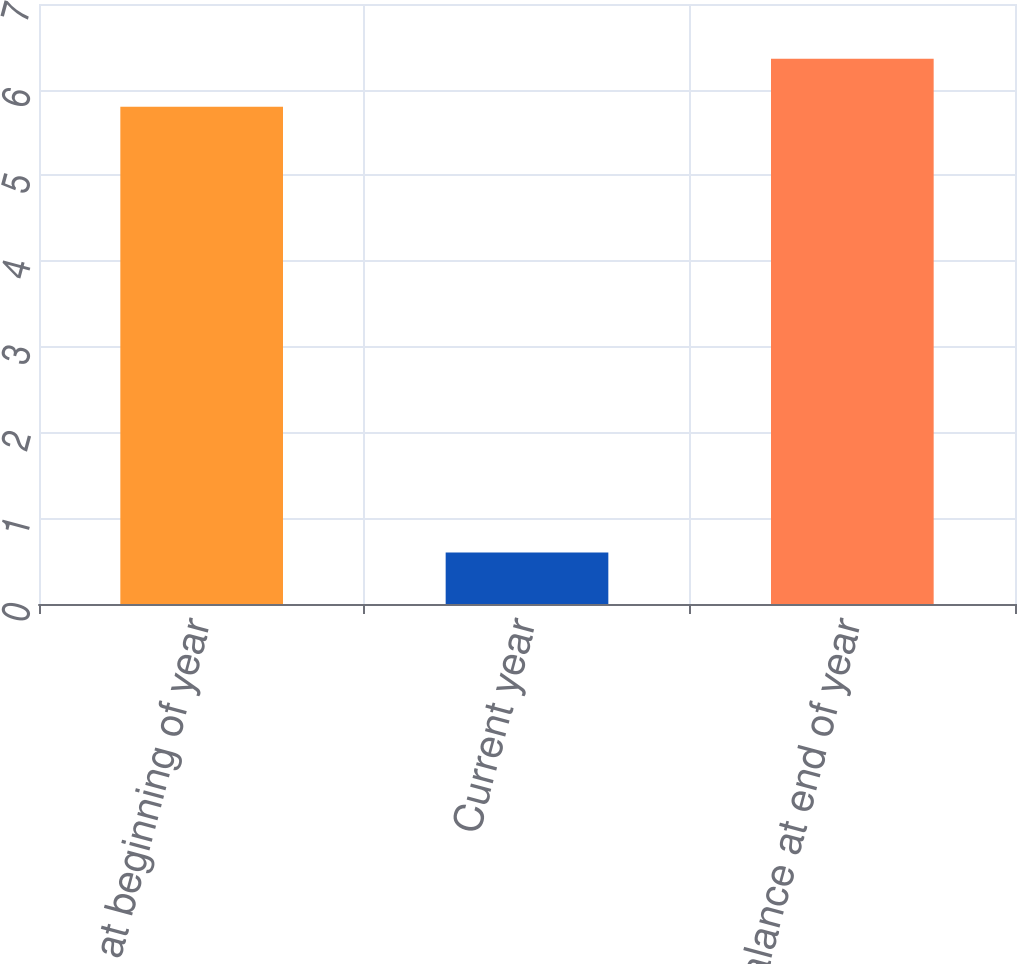<chart> <loc_0><loc_0><loc_500><loc_500><bar_chart><fcel>Balance at beginning of year<fcel>Current year<fcel>Balance at end of year<nl><fcel>5.8<fcel>0.6<fcel>6.36<nl></chart> 